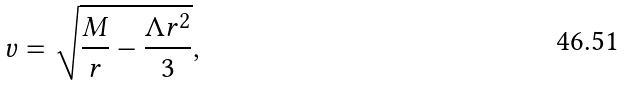Convert formula to latex. <formula><loc_0><loc_0><loc_500><loc_500>v = \sqrt { \frac { M } { r } - \frac { \Lambda r ^ { 2 } } { 3 } } ,</formula> 